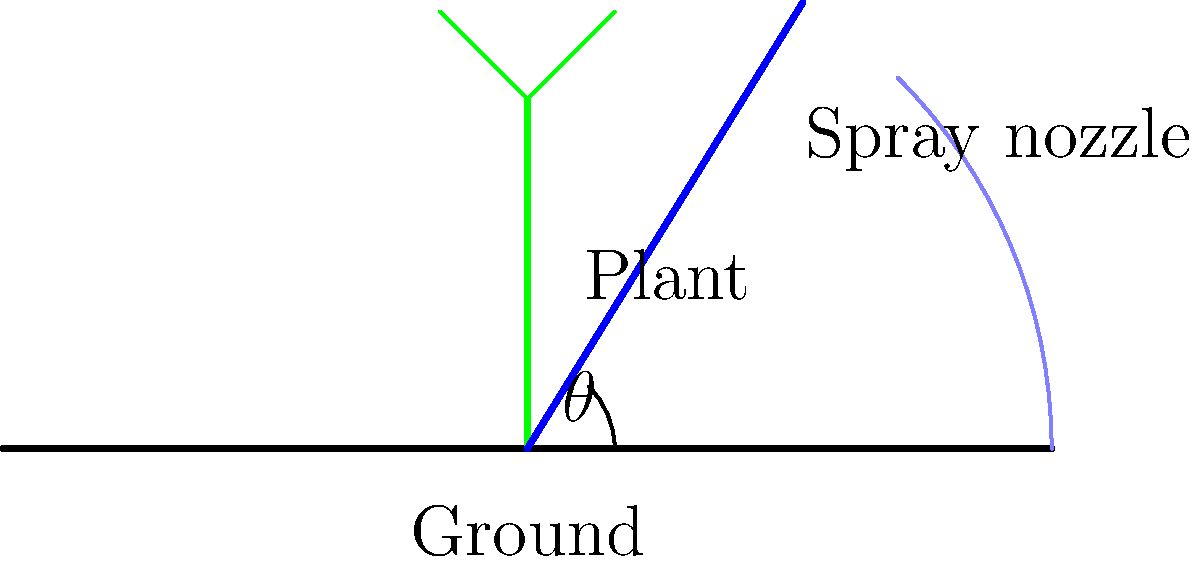What is the optimal angle $\theta$ for watering plants using a spray nozzle to maximize coverage while minimizing water waste? To determine the optimal angle for watering plants using a spray nozzle, we need to consider several factors:

1. Coverage area: The goal is to maximize the area covered by the water spray.
2. Water trajectory: Water follows a parabolic path due to gravity.
3. Plant height: We want to ensure the water reaches the top of the plants.
4. Water conservation: Minimize water waste by preventing overspray.

Step-by-step analysis:

1. A 90-degree angle would create a vertical spray, which is inefficient and doesn't provide good coverage.
2. A very low angle (close to 0 degrees) would result in a narrow spray pattern and might not reach taller plants.
3. The optimal angle should balance height and distance covered.
4. In projectile motion, the maximum range is achieved at a 45-degree angle.
5. However, for watering plants, we want to slightly favor height over distance to ensure coverage of taller plants and to account for air resistance.
6. A range of 50-60 degrees is generally considered optimal for watering plants.
7. Within this range, 55 degrees is often recommended as it provides a good balance between height and distance.

The exact optimal angle may vary slightly depending on factors such as water pressure, nozzle design, and specific plant heights. However, 55 degrees is a good general-purpose angle for most garden watering scenarios.
Answer: 55 degrees 